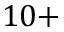<formula> <loc_0><loc_0><loc_500><loc_500>1 0 +</formula> 